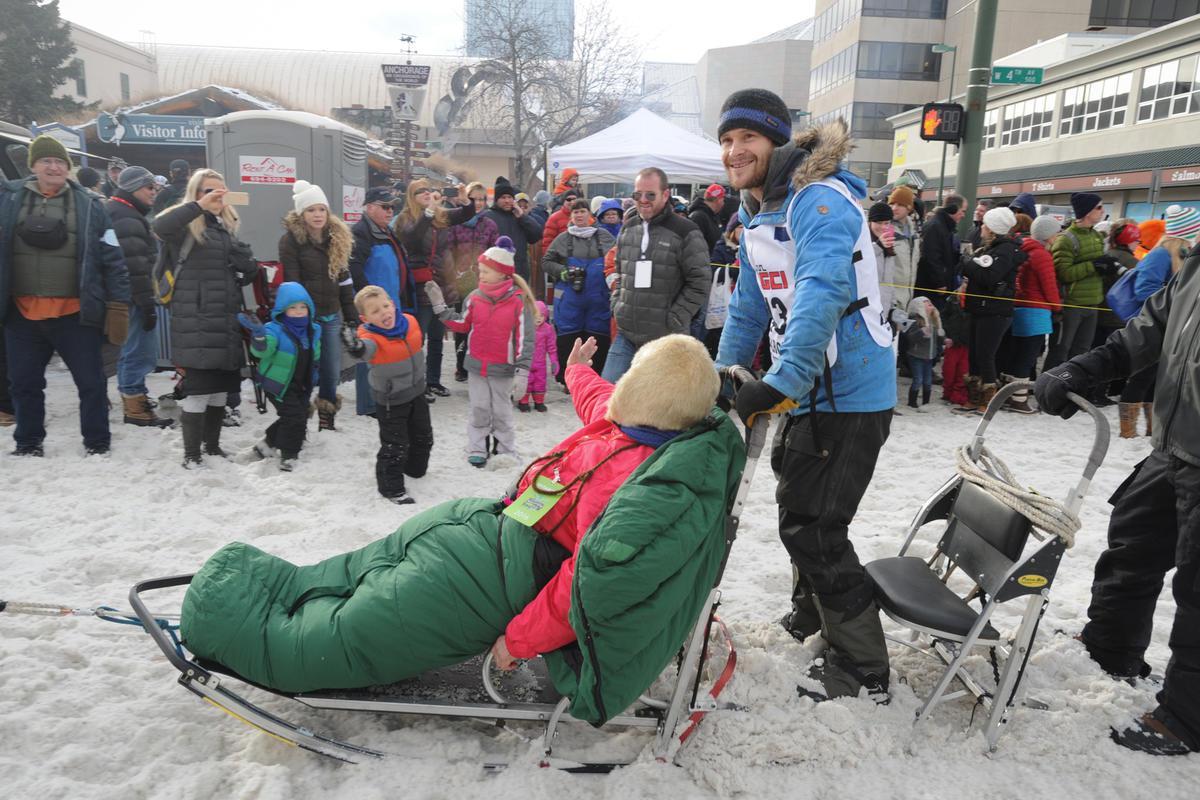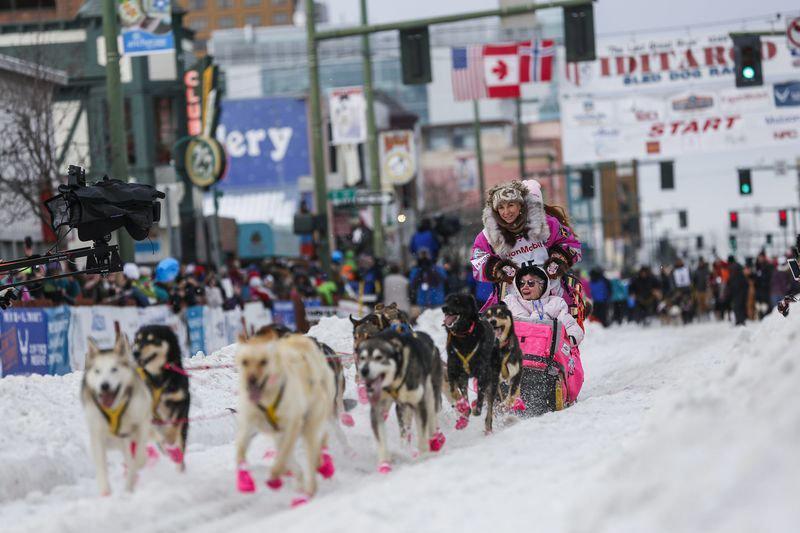The first image is the image on the left, the second image is the image on the right. Analyze the images presented: Is the assertion "One image shows a team of dogs in matching bright-colored booties moving leftward in front of people lining the street." valid? Answer yes or no. Yes. 